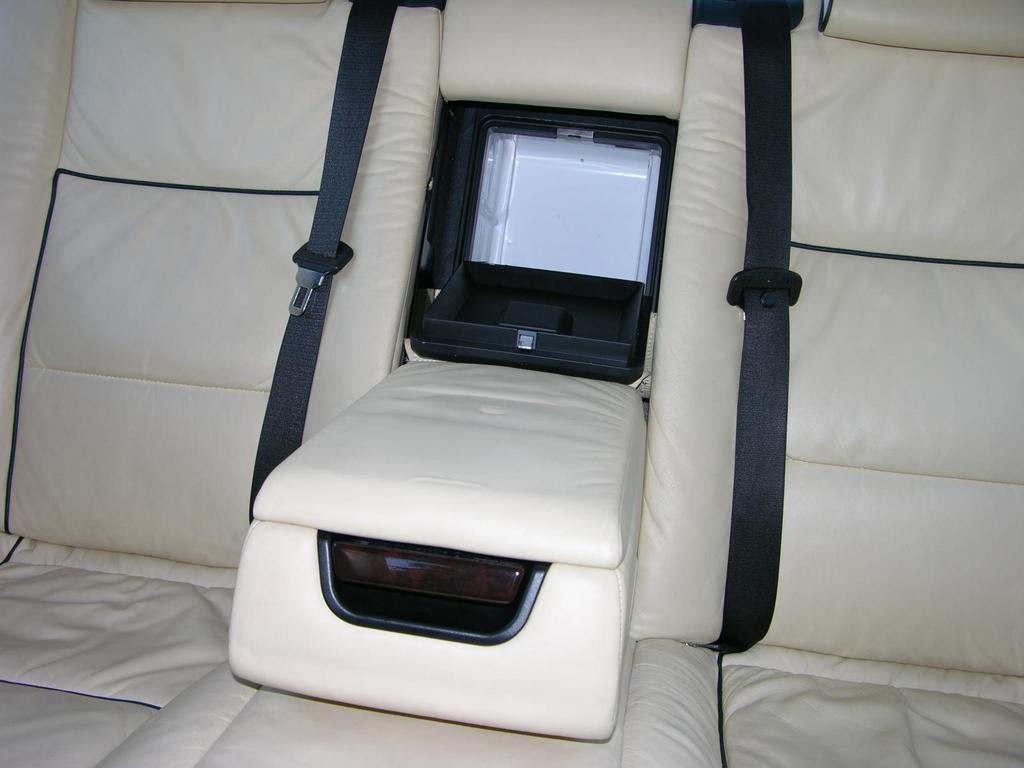What type of setting is depicted in the image? The image shows an inside view of a car. Can you describe any specific features of the car's interior? Unfortunately, the provided facts do not include any specific details about the car's interior. What type of wall decoration can be seen in the image? There is no wall or wall decoration present in the image, as it shows an inside view of a car. 